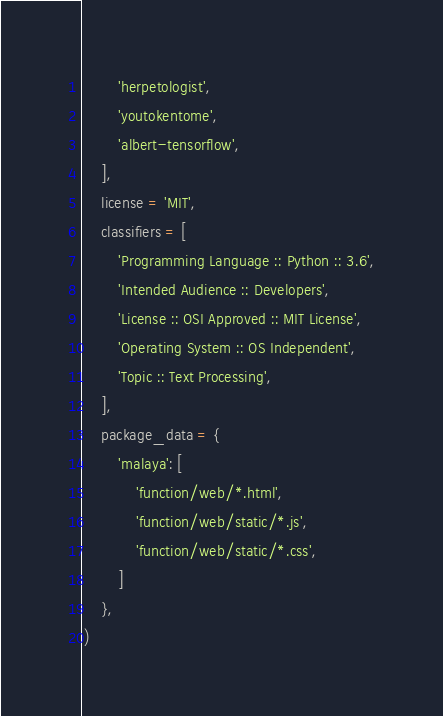Convert code to text. <code><loc_0><loc_0><loc_500><loc_500><_Python_>        'herpetologist',
        'youtokentome',
        'albert-tensorflow',
    ],
    license = 'MIT',
    classifiers = [
        'Programming Language :: Python :: 3.6',
        'Intended Audience :: Developers',
        'License :: OSI Approved :: MIT License',
        'Operating System :: OS Independent',
        'Topic :: Text Processing',
    ],
    package_data = {
        'malaya': [
            'function/web/*.html',
            'function/web/static/*.js',
            'function/web/static/*.css',
        ]
    },
)
</code> 